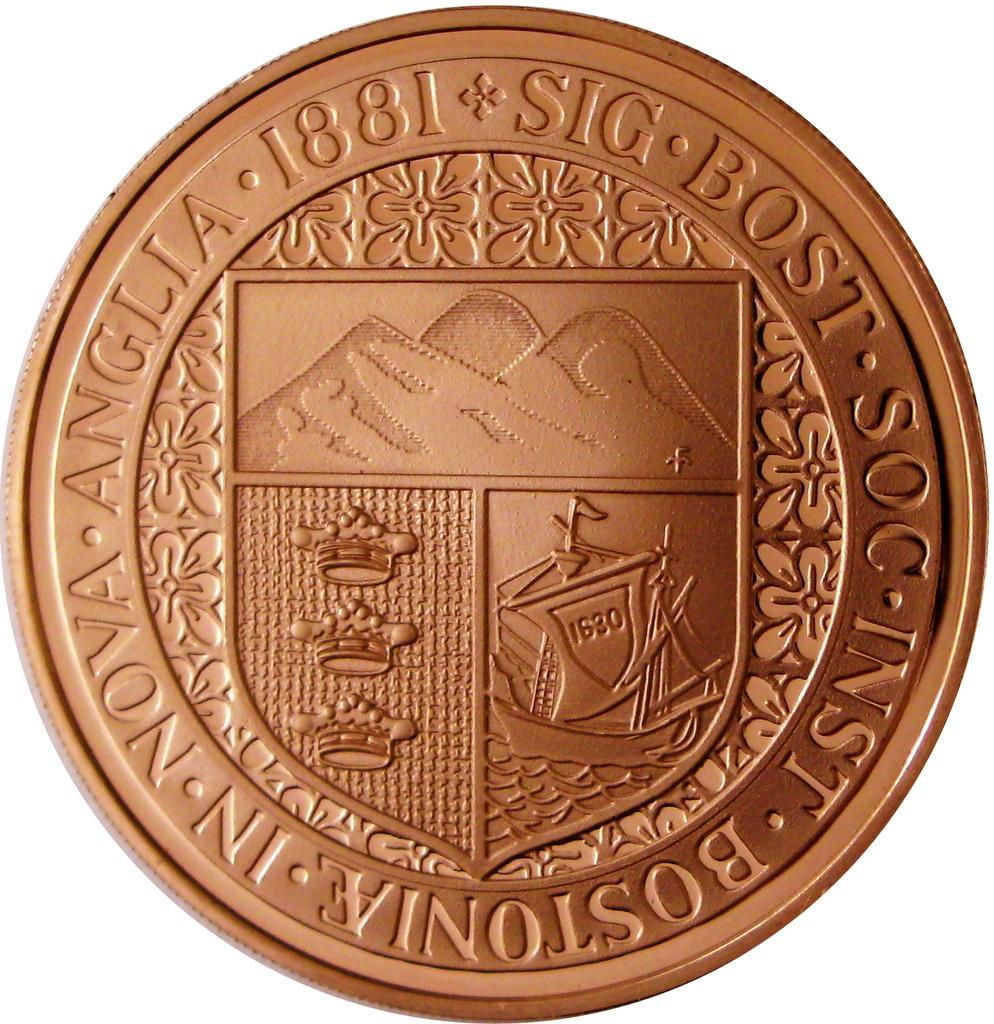<image>
Offer a succinct explanation of the picture presented. A coin that reads Sig bost soc inst bostoniae in nova anglia 1881 